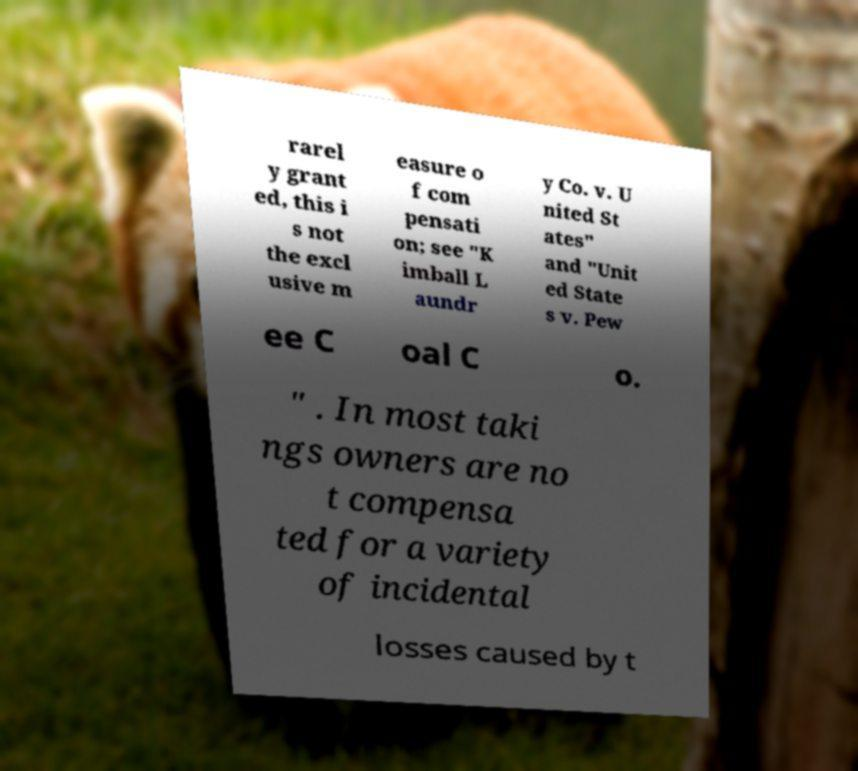Can you accurately transcribe the text from the provided image for me? rarel y grant ed, this i s not the excl usive m easure o f com pensati on; see "K imball L aundr y Co. v. U nited St ates" and "Unit ed State s v. Pew ee C oal C o. " . In most taki ngs owners are no t compensa ted for a variety of incidental losses caused by t 